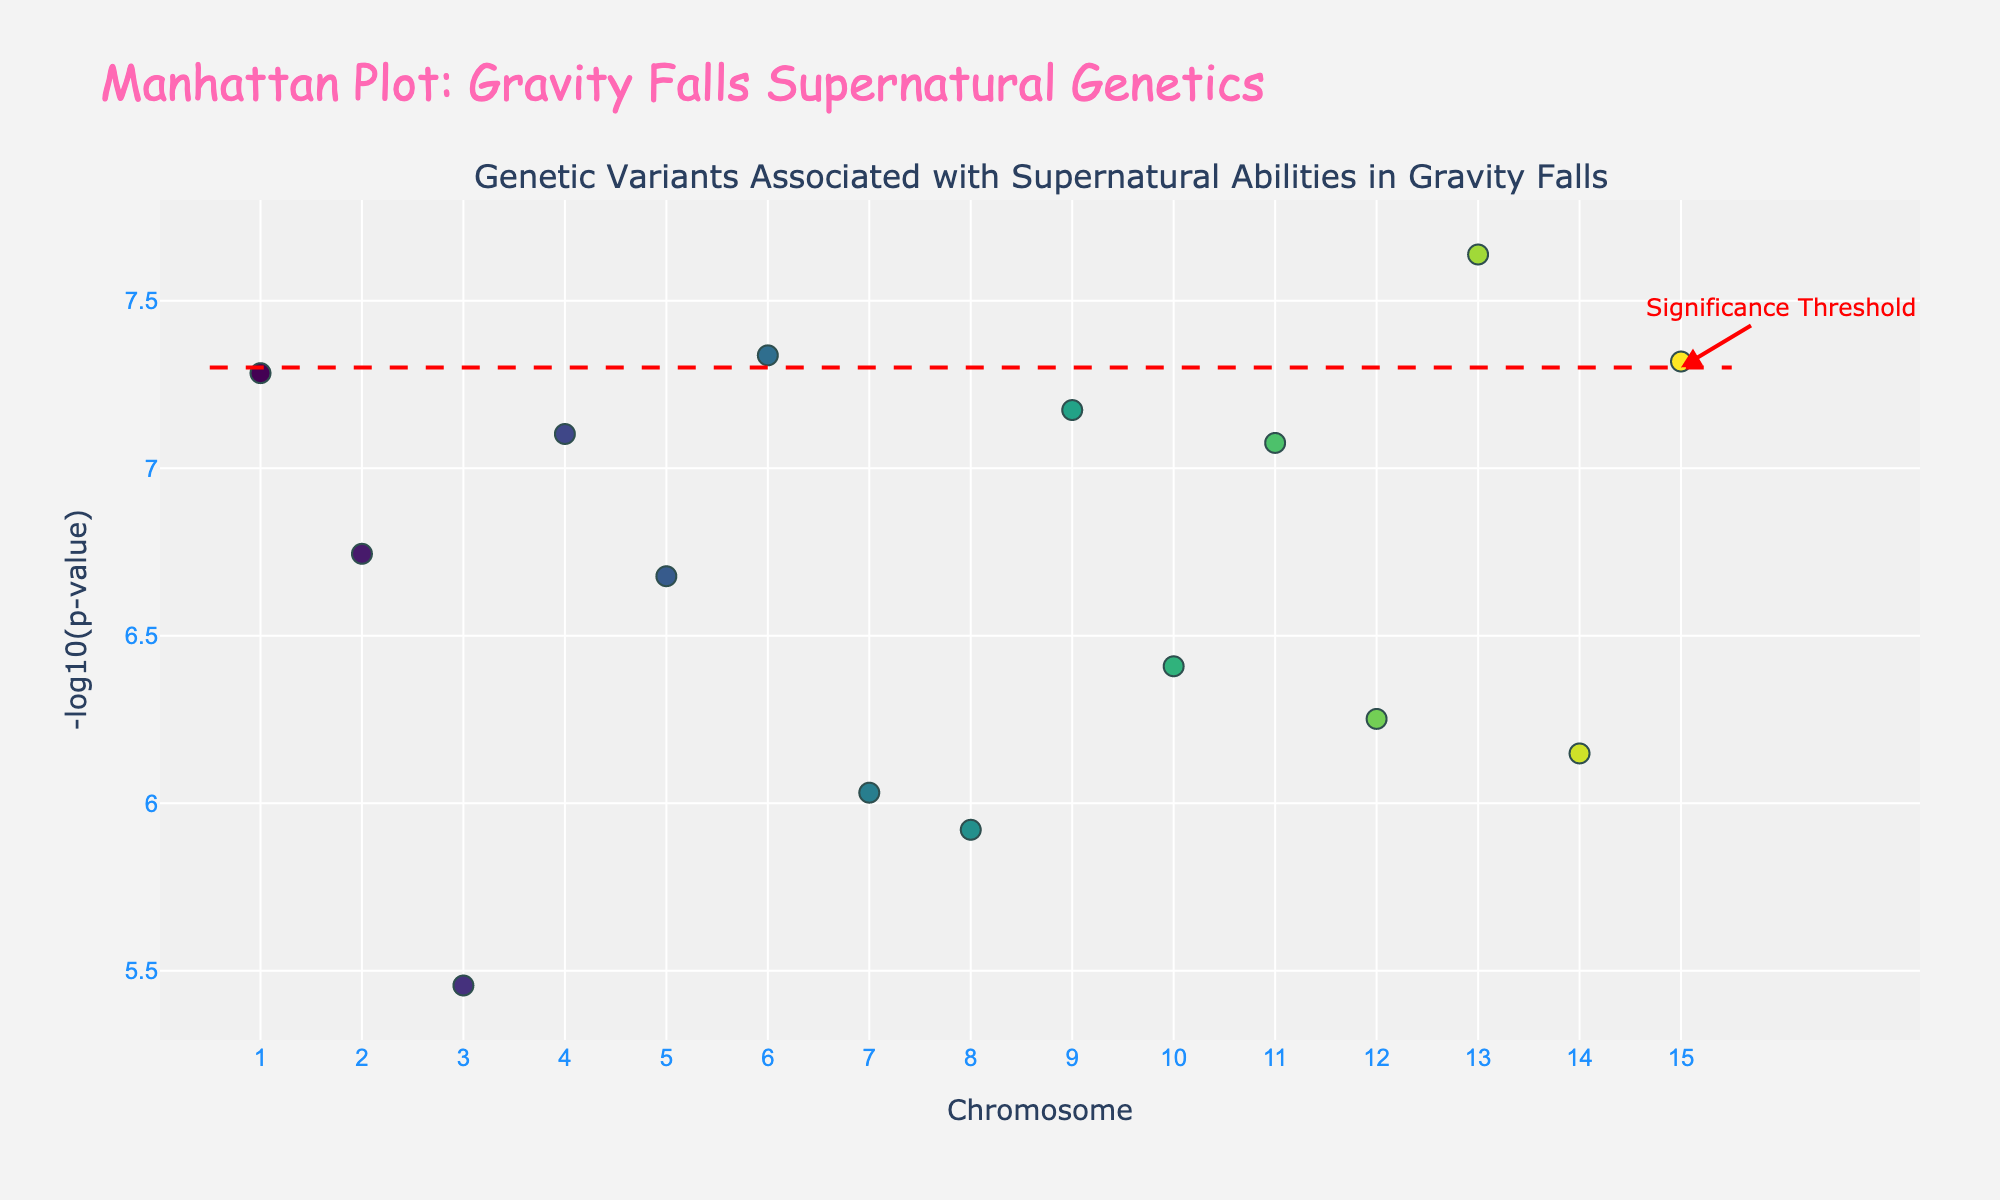What is the title of the plot? The title is prominently displayed at the top of the plot.
Answer: Manhattan Plot: Gravity Falls Supernatural Genetics How many chromosomes are represented in the plot? The x-axis is labeled "Chromosome" and has tick marks ranging from 1 to 15.
Answer: 15 What does the y-axis represent? The y-axis is labeled "-log10(p-value)," indicating it displays the negative log of the p-values.
Answer: -log10(p-value) Which data point has the highest -log10(p-value)? By examining the y-axis values, the highest -log10(p-value) corresponds to the point with the highest position on the y-axis, which is around chromosome 1 (Dipper Pines' paranormal investigation gene).
Answer: Dipper Pines Is there a significance threshold line, and which color is it? The threshold line is denoted by a red dashed line across the plot, with an annotation labeling it as "Significance Threshold."
Answer: Yes, red Which character's gene has a p-value closest to the significance threshold but not below it? To address this, locate the data point closest to the significance threshold line without crossing it, visually comparing positions and y-values.
Answer: Tambry What is the average -log10(p) value for chromosomes 4 and 5? Sum the y-values (-log10(p)) of data points on chromosomes 4 and 5, and divide by the number of points (2). Soos (on chromosome 4) has a value of ~7.10 and Wendy (on chromosome 5) has ~6.68. Average: (7.10 + 6.68)/2.
Answer: 6.89 Which chromosome has a variant associated with a character's ability to communicate with ghosts? Check the hover text for each data point or the provided data, focusing on abilities, and find "Ghost Communication" for Pacifica Northwest, associated with chromosome 9.
Answer: Chromosome 9 Comparing Dipper's and Mabel’s abilities, whose genetic variant has a lower p-value? The y-axis represents -log10(p-value). A higher value here means a lower p-value. Dipper’s gene on chromosome 1 appears higher than Mabel’s on chromosome 2. Therefore, Dipper has a lower p-value.
Answer: Dipper Pines What is the range of -log10(p-values) observed in the plot? Identify the smallest and largest -log10(p-values) on the y-axis. The smallest near ~0.6 (Grunkle Stan on chromosome 3) and the largest near ~7.28 (Dipper on chromosome 1).
Answer: 0.6 to 7.28 